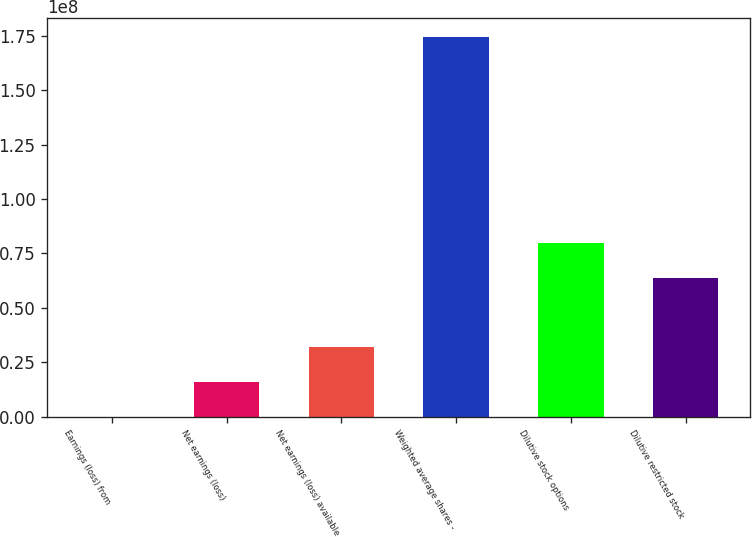Convert chart to OTSL. <chart><loc_0><loc_0><loc_500><loc_500><bar_chart><fcel>Earnings (loss) from<fcel>Net earnings (loss)<fcel>Net earnings (loss) available<fcel>Weighted average shares -<fcel>Dilutive stock options<fcel>Dilutive restricted stock<nl><fcel>4<fcel>1.59796e+07<fcel>3.19593e+07<fcel>1.74305e+08<fcel>7.98982e+07<fcel>6.39185e+07<nl></chart> 